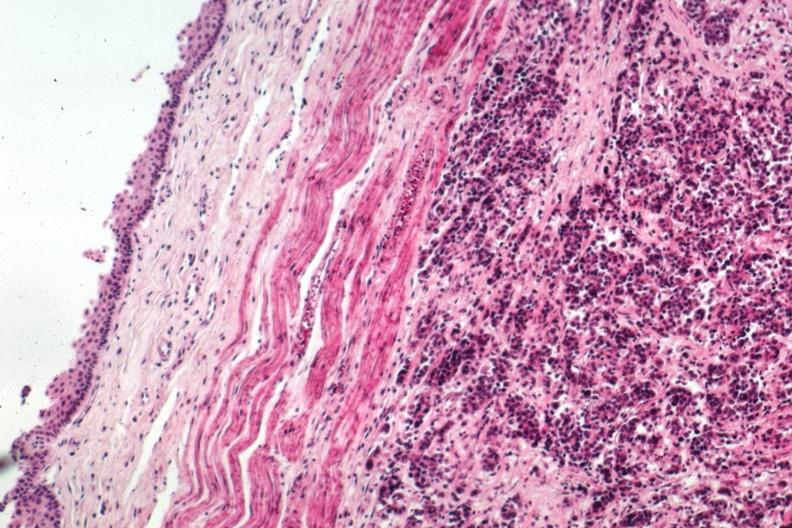s esophagus present?
Answer the question using a single word or phrase. Yes 